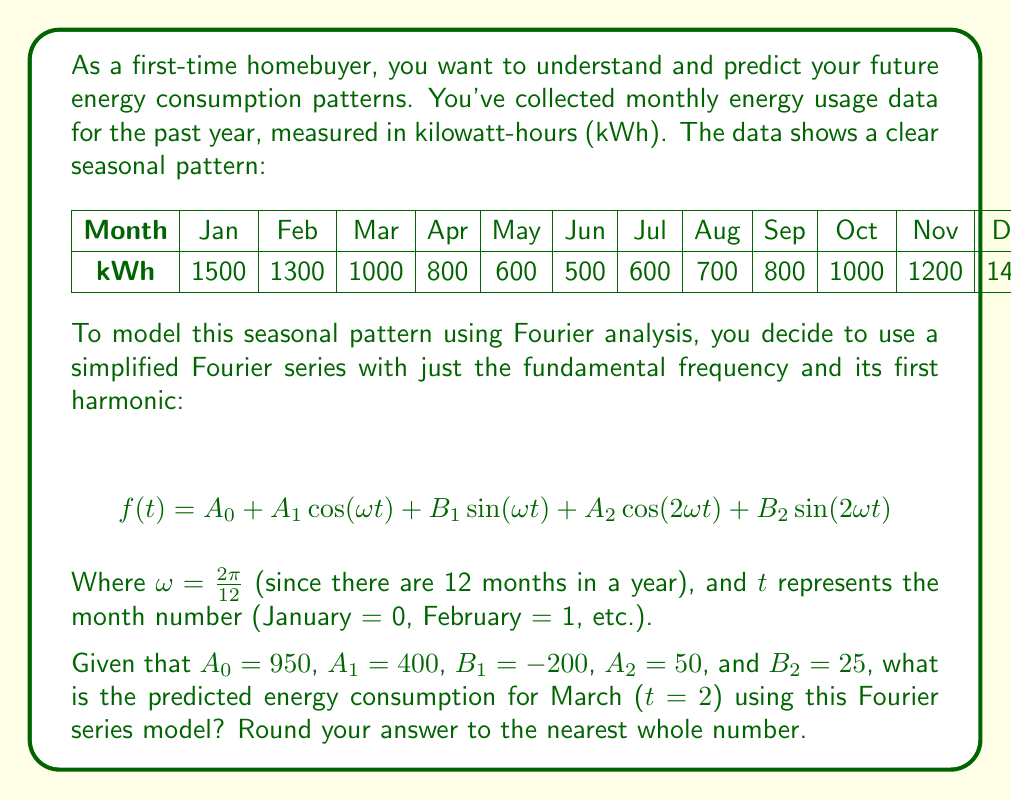Can you solve this math problem? To solve this problem, we need to follow these steps:

1) We have the Fourier series equation:
   $$f(t) = A_0 + A_1 \cos(\omega t) + B_1 \sin(\omega t) + A_2 \cos(2\omega t) + B_2 \sin(2\omega t)$$

2) We're given the following values:
   $A_0 = 950$, $A_1 = 400$, $B_1 = -200$, $A_2 = 50$, $B_2 = 25$, $\omega = \frac{2\pi}{12}$, and $t = 2$ (for March)

3) Let's calculate $\omega t$:
   $$\omega t = \frac{2\pi}{12} \cdot 2 = \frac{\pi}{3}$$

4) Now, let's substitute these values into our equation:

   $$f(2) = 950 + 400 \cos(\frac{\pi}{3}) + (-200) \sin(\frac{\pi}{3}) + 50 \cos(\frac{2\pi}{3}) + 25 \sin(\frac{2\pi}{3})$$

5) Let's calculate each trigonometric term:
   $\cos(\frac{\pi}{3}) = 0.5$
   $\sin(\frac{\pi}{3}) = \frac{\sqrt{3}}{2} \approx 0.866$
   $\cos(\frac{2\pi}{3}) = -0.5$
   $\sin(\frac{2\pi}{3}) = \frac{\sqrt{3}}{2} \approx 0.866$

6) Now, let's substitute these values:

   $$f(2) = 950 + 400(0.5) + (-200)(0.866) + 50(-0.5) + 25(0.866)$$

7) Let's calculate each term:
   950
   200
   -173.2
   -25
   21.65

8) Sum up all terms:
   $$950 + 200 - 173.2 - 25 + 21.65 = 973.45$$

9) Rounding to the nearest whole number:
   973.45 ≈ 973
Answer: 973 kWh 